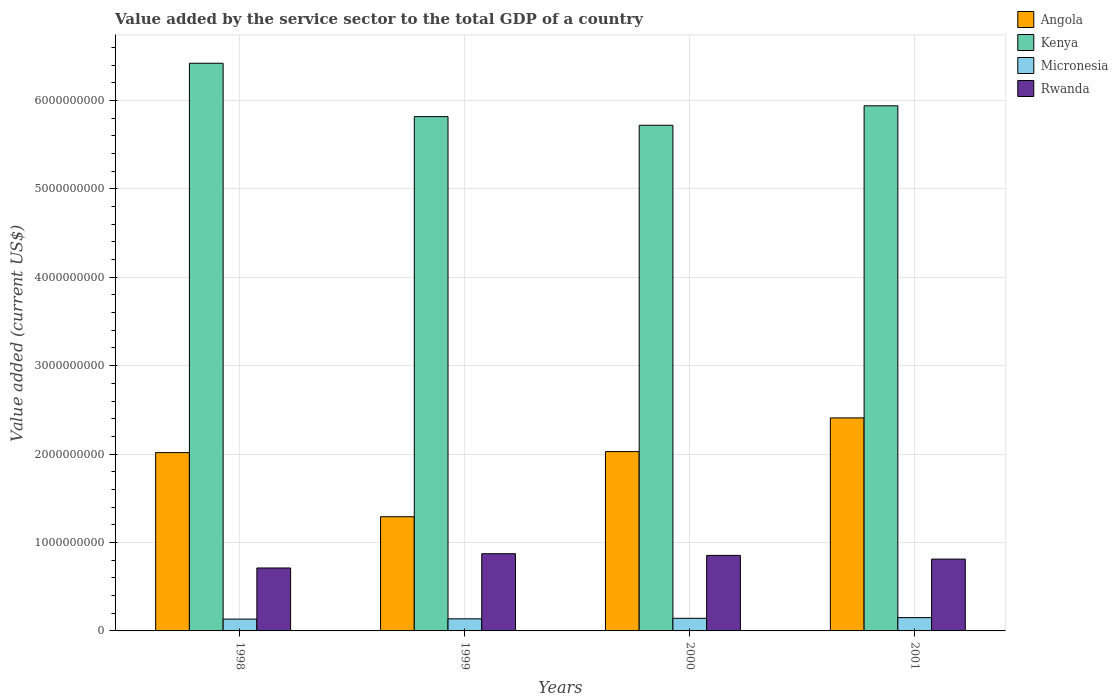Are the number of bars on each tick of the X-axis equal?
Your answer should be compact. Yes. How many bars are there on the 3rd tick from the left?
Your response must be concise. 4. In how many cases, is the number of bars for a given year not equal to the number of legend labels?
Provide a short and direct response. 0. What is the value added by the service sector to the total GDP in Kenya in 2001?
Provide a succinct answer. 5.94e+09. Across all years, what is the maximum value added by the service sector to the total GDP in Micronesia?
Provide a short and direct response. 1.50e+08. Across all years, what is the minimum value added by the service sector to the total GDP in Angola?
Provide a short and direct response. 1.29e+09. In which year was the value added by the service sector to the total GDP in Angola minimum?
Your answer should be very brief. 1999. What is the total value added by the service sector to the total GDP in Angola in the graph?
Give a very brief answer. 7.75e+09. What is the difference between the value added by the service sector to the total GDP in Angola in 1998 and that in 2000?
Your response must be concise. -1.14e+07. What is the difference between the value added by the service sector to the total GDP in Kenya in 2001 and the value added by the service sector to the total GDP in Micronesia in 1999?
Your response must be concise. 5.80e+09. What is the average value added by the service sector to the total GDP in Angola per year?
Offer a terse response. 1.94e+09. In the year 1999, what is the difference between the value added by the service sector to the total GDP in Micronesia and value added by the service sector to the total GDP in Angola?
Provide a succinct answer. -1.15e+09. What is the ratio of the value added by the service sector to the total GDP in Kenya in 1998 to that in 1999?
Your response must be concise. 1.1. Is the difference between the value added by the service sector to the total GDP in Micronesia in 1999 and 2001 greater than the difference between the value added by the service sector to the total GDP in Angola in 1999 and 2001?
Make the answer very short. Yes. What is the difference between the highest and the second highest value added by the service sector to the total GDP in Micronesia?
Give a very brief answer. 7.80e+06. What is the difference between the highest and the lowest value added by the service sector to the total GDP in Kenya?
Keep it short and to the point. 7.01e+08. In how many years, is the value added by the service sector to the total GDP in Rwanda greater than the average value added by the service sector to the total GDP in Rwanda taken over all years?
Offer a very short reply. 2. Is the sum of the value added by the service sector to the total GDP in Kenya in 1999 and 2001 greater than the maximum value added by the service sector to the total GDP in Micronesia across all years?
Your response must be concise. Yes. What does the 1st bar from the left in 2001 represents?
Your answer should be very brief. Angola. What does the 1st bar from the right in 1998 represents?
Provide a short and direct response. Rwanda. What is the difference between two consecutive major ticks on the Y-axis?
Your answer should be very brief. 1.00e+09. Are the values on the major ticks of Y-axis written in scientific E-notation?
Your answer should be very brief. No. Does the graph contain any zero values?
Ensure brevity in your answer.  No. Does the graph contain grids?
Provide a succinct answer. Yes. How are the legend labels stacked?
Provide a short and direct response. Vertical. What is the title of the graph?
Ensure brevity in your answer.  Value added by the service sector to the total GDP of a country. What is the label or title of the Y-axis?
Keep it short and to the point. Value added (current US$). What is the Value added (current US$) of Angola in 1998?
Ensure brevity in your answer.  2.02e+09. What is the Value added (current US$) in Kenya in 1998?
Ensure brevity in your answer.  6.42e+09. What is the Value added (current US$) in Micronesia in 1998?
Your answer should be very brief. 1.34e+08. What is the Value added (current US$) in Rwanda in 1998?
Offer a very short reply. 7.12e+08. What is the Value added (current US$) in Angola in 1999?
Your answer should be very brief. 1.29e+09. What is the Value added (current US$) in Kenya in 1999?
Your answer should be compact. 5.82e+09. What is the Value added (current US$) in Micronesia in 1999?
Keep it short and to the point. 1.37e+08. What is the Value added (current US$) of Rwanda in 1999?
Give a very brief answer. 8.73e+08. What is the Value added (current US$) of Angola in 2000?
Provide a succinct answer. 2.03e+09. What is the Value added (current US$) of Kenya in 2000?
Offer a very short reply. 5.72e+09. What is the Value added (current US$) in Micronesia in 2000?
Offer a terse response. 1.43e+08. What is the Value added (current US$) of Rwanda in 2000?
Your answer should be very brief. 8.54e+08. What is the Value added (current US$) in Angola in 2001?
Make the answer very short. 2.41e+09. What is the Value added (current US$) of Kenya in 2001?
Your response must be concise. 5.94e+09. What is the Value added (current US$) in Micronesia in 2001?
Offer a very short reply. 1.50e+08. What is the Value added (current US$) in Rwanda in 2001?
Provide a short and direct response. 8.12e+08. Across all years, what is the maximum Value added (current US$) of Angola?
Give a very brief answer. 2.41e+09. Across all years, what is the maximum Value added (current US$) in Kenya?
Offer a terse response. 6.42e+09. Across all years, what is the maximum Value added (current US$) in Micronesia?
Offer a terse response. 1.50e+08. Across all years, what is the maximum Value added (current US$) of Rwanda?
Offer a terse response. 8.73e+08. Across all years, what is the minimum Value added (current US$) in Angola?
Your answer should be compact. 1.29e+09. Across all years, what is the minimum Value added (current US$) of Kenya?
Ensure brevity in your answer.  5.72e+09. Across all years, what is the minimum Value added (current US$) of Micronesia?
Ensure brevity in your answer.  1.34e+08. Across all years, what is the minimum Value added (current US$) in Rwanda?
Provide a succinct answer. 7.12e+08. What is the total Value added (current US$) of Angola in the graph?
Your answer should be very brief. 7.75e+09. What is the total Value added (current US$) of Kenya in the graph?
Provide a short and direct response. 2.39e+1. What is the total Value added (current US$) of Micronesia in the graph?
Make the answer very short. 5.64e+08. What is the total Value added (current US$) of Rwanda in the graph?
Your answer should be very brief. 3.25e+09. What is the difference between the Value added (current US$) in Angola in 1998 and that in 1999?
Offer a terse response. 7.25e+08. What is the difference between the Value added (current US$) in Kenya in 1998 and that in 1999?
Your answer should be compact. 6.03e+08. What is the difference between the Value added (current US$) of Micronesia in 1998 and that in 1999?
Give a very brief answer. -3.17e+06. What is the difference between the Value added (current US$) of Rwanda in 1998 and that in 1999?
Your response must be concise. -1.61e+08. What is the difference between the Value added (current US$) in Angola in 1998 and that in 2000?
Make the answer very short. -1.14e+07. What is the difference between the Value added (current US$) of Kenya in 1998 and that in 2000?
Your response must be concise. 7.01e+08. What is the difference between the Value added (current US$) in Micronesia in 1998 and that in 2000?
Make the answer very short. -8.96e+06. What is the difference between the Value added (current US$) of Rwanda in 1998 and that in 2000?
Ensure brevity in your answer.  -1.42e+08. What is the difference between the Value added (current US$) in Angola in 1998 and that in 2001?
Provide a succinct answer. -3.93e+08. What is the difference between the Value added (current US$) of Kenya in 1998 and that in 2001?
Your response must be concise. 4.81e+08. What is the difference between the Value added (current US$) in Micronesia in 1998 and that in 2001?
Give a very brief answer. -1.68e+07. What is the difference between the Value added (current US$) in Rwanda in 1998 and that in 2001?
Offer a very short reply. -1.01e+08. What is the difference between the Value added (current US$) in Angola in 1999 and that in 2000?
Offer a terse response. -7.36e+08. What is the difference between the Value added (current US$) of Kenya in 1999 and that in 2000?
Offer a very short reply. 9.78e+07. What is the difference between the Value added (current US$) of Micronesia in 1999 and that in 2000?
Offer a terse response. -5.79e+06. What is the difference between the Value added (current US$) in Rwanda in 1999 and that in 2000?
Keep it short and to the point. 1.90e+07. What is the difference between the Value added (current US$) of Angola in 1999 and that in 2001?
Give a very brief answer. -1.12e+09. What is the difference between the Value added (current US$) of Kenya in 1999 and that in 2001?
Your answer should be very brief. -1.22e+08. What is the difference between the Value added (current US$) of Micronesia in 1999 and that in 2001?
Offer a very short reply. -1.36e+07. What is the difference between the Value added (current US$) in Rwanda in 1999 and that in 2001?
Your answer should be very brief. 6.08e+07. What is the difference between the Value added (current US$) of Angola in 2000 and that in 2001?
Provide a succinct answer. -3.81e+08. What is the difference between the Value added (current US$) in Kenya in 2000 and that in 2001?
Provide a short and direct response. -2.20e+08. What is the difference between the Value added (current US$) in Micronesia in 2000 and that in 2001?
Your answer should be very brief. -7.80e+06. What is the difference between the Value added (current US$) of Rwanda in 2000 and that in 2001?
Make the answer very short. 4.18e+07. What is the difference between the Value added (current US$) of Angola in 1998 and the Value added (current US$) of Kenya in 1999?
Make the answer very short. -3.80e+09. What is the difference between the Value added (current US$) in Angola in 1998 and the Value added (current US$) in Micronesia in 1999?
Your response must be concise. 1.88e+09. What is the difference between the Value added (current US$) in Angola in 1998 and the Value added (current US$) in Rwanda in 1999?
Your answer should be compact. 1.14e+09. What is the difference between the Value added (current US$) in Kenya in 1998 and the Value added (current US$) in Micronesia in 1999?
Ensure brevity in your answer.  6.28e+09. What is the difference between the Value added (current US$) in Kenya in 1998 and the Value added (current US$) in Rwanda in 1999?
Give a very brief answer. 5.55e+09. What is the difference between the Value added (current US$) of Micronesia in 1998 and the Value added (current US$) of Rwanda in 1999?
Provide a short and direct response. -7.39e+08. What is the difference between the Value added (current US$) in Angola in 1998 and the Value added (current US$) in Kenya in 2000?
Give a very brief answer. -3.70e+09. What is the difference between the Value added (current US$) in Angola in 1998 and the Value added (current US$) in Micronesia in 2000?
Provide a succinct answer. 1.87e+09. What is the difference between the Value added (current US$) in Angola in 1998 and the Value added (current US$) in Rwanda in 2000?
Your answer should be very brief. 1.16e+09. What is the difference between the Value added (current US$) in Kenya in 1998 and the Value added (current US$) in Micronesia in 2000?
Your answer should be very brief. 6.28e+09. What is the difference between the Value added (current US$) in Kenya in 1998 and the Value added (current US$) in Rwanda in 2000?
Give a very brief answer. 5.57e+09. What is the difference between the Value added (current US$) of Micronesia in 1998 and the Value added (current US$) of Rwanda in 2000?
Make the answer very short. -7.20e+08. What is the difference between the Value added (current US$) of Angola in 1998 and the Value added (current US$) of Kenya in 2001?
Offer a terse response. -3.92e+09. What is the difference between the Value added (current US$) of Angola in 1998 and the Value added (current US$) of Micronesia in 2001?
Your response must be concise. 1.87e+09. What is the difference between the Value added (current US$) in Angola in 1998 and the Value added (current US$) in Rwanda in 2001?
Make the answer very short. 1.20e+09. What is the difference between the Value added (current US$) of Kenya in 1998 and the Value added (current US$) of Micronesia in 2001?
Your answer should be compact. 6.27e+09. What is the difference between the Value added (current US$) in Kenya in 1998 and the Value added (current US$) in Rwanda in 2001?
Provide a short and direct response. 5.61e+09. What is the difference between the Value added (current US$) in Micronesia in 1998 and the Value added (current US$) in Rwanda in 2001?
Offer a terse response. -6.79e+08. What is the difference between the Value added (current US$) of Angola in 1999 and the Value added (current US$) of Kenya in 2000?
Ensure brevity in your answer.  -4.43e+09. What is the difference between the Value added (current US$) in Angola in 1999 and the Value added (current US$) in Micronesia in 2000?
Offer a very short reply. 1.15e+09. What is the difference between the Value added (current US$) in Angola in 1999 and the Value added (current US$) in Rwanda in 2000?
Make the answer very short. 4.38e+08. What is the difference between the Value added (current US$) in Kenya in 1999 and the Value added (current US$) in Micronesia in 2000?
Give a very brief answer. 5.67e+09. What is the difference between the Value added (current US$) of Kenya in 1999 and the Value added (current US$) of Rwanda in 2000?
Offer a very short reply. 4.96e+09. What is the difference between the Value added (current US$) of Micronesia in 1999 and the Value added (current US$) of Rwanda in 2000?
Keep it short and to the point. -7.17e+08. What is the difference between the Value added (current US$) of Angola in 1999 and the Value added (current US$) of Kenya in 2001?
Give a very brief answer. -4.65e+09. What is the difference between the Value added (current US$) in Angola in 1999 and the Value added (current US$) in Micronesia in 2001?
Your answer should be very brief. 1.14e+09. What is the difference between the Value added (current US$) in Angola in 1999 and the Value added (current US$) in Rwanda in 2001?
Provide a short and direct response. 4.79e+08. What is the difference between the Value added (current US$) of Kenya in 1999 and the Value added (current US$) of Micronesia in 2001?
Your answer should be very brief. 5.67e+09. What is the difference between the Value added (current US$) in Kenya in 1999 and the Value added (current US$) in Rwanda in 2001?
Ensure brevity in your answer.  5.00e+09. What is the difference between the Value added (current US$) in Micronesia in 1999 and the Value added (current US$) in Rwanda in 2001?
Keep it short and to the point. -6.76e+08. What is the difference between the Value added (current US$) in Angola in 2000 and the Value added (current US$) in Kenya in 2001?
Provide a succinct answer. -3.91e+09. What is the difference between the Value added (current US$) of Angola in 2000 and the Value added (current US$) of Micronesia in 2001?
Give a very brief answer. 1.88e+09. What is the difference between the Value added (current US$) in Angola in 2000 and the Value added (current US$) in Rwanda in 2001?
Your answer should be very brief. 1.22e+09. What is the difference between the Value added (current US$) in Kenya in 2000 and the Value added (current US$) in Micronesia in 2001?
Make the answer very short. 5.57e+09. What is the difference between the Value added (current US$) of Kenya in 2000 and the Value added (current US$) of Rwanda in 2001?
Your answer should be compact. 4.91e+09. What is the difference between the Value added (current US$) in Micronesia in 2000 and the Value added (current US$) in Rwanda in 2001?
Keep it short and to the point. -6.70e+08. What is the average Value added (current US$) in Angola per year?
Your answer should be compact. 1.94e+09. What is the average Value added (current US$) of Kenya per year?
Make the answer very short. 5.97e+09. What is the average Value added (current US$) of Micronesia per year?
Offer a very short reply. 1.41e+08. What is the average Value added (current US$) of Rwanda per year?
Offer a very short reply. 8.13e+08. In the year 1998, what is the difference between the Value added (current US$) in Angola and Value added (current US$) in Kenya?
Offer a terse response. -4.40e+09. In the year 1998, what is the difference between the Value added (current US$) of Angola and Value added (current US$) of Micronesia?
Make the answer very short. 1.88e+09. In the year 1998, what is the difference between the Value added (current US$) in Angola and Value added (current US$) in Rwanda?
Make the answer very short. 1.30e+09. In the year 1998, what is the difference between the Value added (current US$) in Kenya and Value added (current US$) in Micronesia?
Keep it short and to the point. 6.29e+09. In the year 1998, what is the difference between the Value added (current US$) in Kenya and Value added (current US$) in Rwanda?
Your answer should be compact. 5.71e+09. In the year 1998, what is the difference between the Value added (current US$) of Micronesia and Value added (current US$) of Rwanda?
Ensure brevity in your answer.  -5.78e+08. In the year 1999, what is the difference between the Value added (current US$) of Angola and Value added (current US$) of Kenya?
Make the answer very short. -4.52e+09. In the year 1999, what is the difference between the Value added (current US$) of Angola and Value added (current US$) of Micronesia?
Your response must be concise. 1.15e+09. In the year 1999, what is the difference between the Value added (current US$) in Angola and Value added (current US$) in Rwanda?
Keep it short and to the point. 4.19e+08. In the year 1999, what is the difference between the Value added (current US$) of Kenya and Value added (current US$) of Micronesia?
Offer a terse response. 5.68e+09. In the year 1999, what is the difference between the Value added (current US$) of Kenya and Value added (current US$) of Rwanda?
Keep it short and to the point. 4.94e+09. In the year 1999, what is the difference between the Value added (current US$) in Micronesia and Value added (current US$) in Rwanda?
Your answer should be very brief. -7.36e+08. In the year 2000, what is the difference between the Value added (current US$) of Angola and Value added (current US$) of Kenya?
Give a very brief answer. -3.69e+09. In the year 2000, what is the difference between the Value added (current US$) of Angola and Value added (current US$) of Micronesia?
Provide a short and direct response. 1.89e+09. In the year 2000, what is the difference between the Value added (current US$) in Angola and Value added (current US$) in Rwanda?
Your response must be concise. 1.17e+09. In the year 2000, what is the difference between the Value added (current US$) of Kenya and Value added (current US$) of Micronesia?
Offer a very short reply. 5.58e+09. In the year 2000, what is the difference between the Value added (current US$) of Kenya and Value added (current US$) of Rwanda?
Your answer should be very brief. 4.86e+09. In the year 2000, what is the difference between the Value added (current US$) in Micronesia and Value added (current US$) in Rwanda?
Offer a very short reply. -7.12e+08. In the year 2001, what is the difference between the Value added (current US$) in Angola and Value added (current US$) in Kenya?
Your answer should be compact. -3.53e+09. In the year 2001, what is the difference between the Value added (current US$) of Angola and Value added (current US$) of Micronesia?
Your answer should be very brief. 2.26e+09. In the year 2001, what is the difference between the Value added (current US$) of Angola and Value added (current US$) of Rwanda?
Your answer should be compact. 1.60e+09. In the year 2001, what is the difference between the Value added (current US$) of Kenya and Value added (current US$) of Micronesia?
Offer a terse response. 5.79e+09. In the year 2001, what is the difference between the Value added (current US$) in Kenya and Value added (current US$) in Rwanda?
Your answer should be compact. 5.13e+09. In the year 2001, what is the difference between the Value added (current US$) in Micronesia and Value added (current US$) in Rwanda?
Provide a short and direct response. -6.62e+08. What is the ratio of the Value added (current US$) in Angola in 1998 to that in 1999?
Ensure brevity in your answer.  1.56. What is the ratio of the Value added (current US$) in Kenya in 1998 to that in 1999?
Make the answer very short. 1.1. What is the ratio of the Value added (current US$) in Micronesia in 1998 to that in 1999?
Offer a very short reply. 0.98. What is the ratio of the Value added (current US$) in Rwanda in 1998 to that in 1999?
Your answer should be very brief. 0.82. What is the ratio of the Value added (current US$) in Kenya in 1998 to that in 2000?
Make the answer very short. 1.12. What is the ratio of the Value added (current US$) in Micronesia in 1998 to that in 2000?
Ensure brevity in your answer.  0.94. What is the ratio of the Value added (current US$) in Rwanda in 1998 to that in 2000?
Keep it short and to the point. 0.83. What is the ratio of the Value added (current US$) in Angola in 1998 to that in 2001?
Give a very brief answer. 0.84. What is the ratio of the Value added (current US$) of Kenya in 1998 to that in 2001?
Your answer should be very brief. 1.08. What is the ratio of the Value added (current US$) of Micronesia in 1998 to that in 2001?
Offer a terse response. 0.89. What is the ratio of the Value added (current US$) in Rwanda in 1998 to that in 2001?
Offer a very short reply. 0.88. What is the ratio of the Value added (current US$) of Angola in 1999 to that in 2000?
Offer a terse response. 0.64. What is the ratio of the Value added (current US$) in Kenya in 1999 to that in 2000?
Offer a terse response. 1.02. What is the ratio of the Value added (current US$) of Micronesia in 1999 to that in 2000?
Offer a very short reply. 0.96. What is the ratio of the Value added (current US$) in Rwanda in 1999 to that in 2000?
Offer a terse response. 1.02. What is the ratio of the Value added (current US$) in Angola in 1999 to that in 2001?
Make the answer very short. 0.54. What is the ratio of the Value added (current US$) of Kenya in 1999 to that in 2001?
Provide a short and direct response. 0.98. What is the ratio of the Value added (current US$) in Micronesia in 1999 to that in 2001?
Provide a succinct answer. 0.91. What is the ratio of the Value added (current US$) of Rwanda in 1999 to that in 2001?
Give a very brief answer. 1.07. What is the ratio of the Value added (current US$) of Angola in 2000 to that in 2001?
Your response must be concise. 0.84. What is the ratio of the Value added (current US$) of Kenya in 2000 to that in 2001?
Your answer should be compact. 0.96. What is the ratio of the Value added (current US$) in Micronesia in 2000 to that in 2001?
Give a very brief answer. 0.95. What is the ratio of the Value added (current US$) of Rwanda in 2000 to that in 2001?
Offer a very short reply. 1.05. What is the difference between the highest and the second highest Value added (current US$) of Angola?
Your response must be concise. 3.81e+08. What is the difference between the highest and the second highest Value added (current US$) in Kenya?
Offer a very short reply. 4.81e+08. What is the difference between the highest and the second highest Value added (current US$) in Micronesia?
Keep it short and to the point. 7.80e+06. What is the difference between the highest and the second highest Value added (current US$) of Rwanda?
Give a very brief answer. 1.90e+07. What is the difference between the highest and the lowest Value added (current US$) in Angola?
Provide a succinct answer. 1.12e+09. What is the difference between the highest and the lowest Value added (current US$) in Kenya?
Offer a very short reply. 7.01e+08. What is the difference between the highest and the lowest Value added (current US$) of Micronesia?
Your response must be concise. 1.68e+07. What is the difference between the highest and the lowest Value added (current US$) of Rwanda?
Provide a short and direct response. 1.61e+08. 